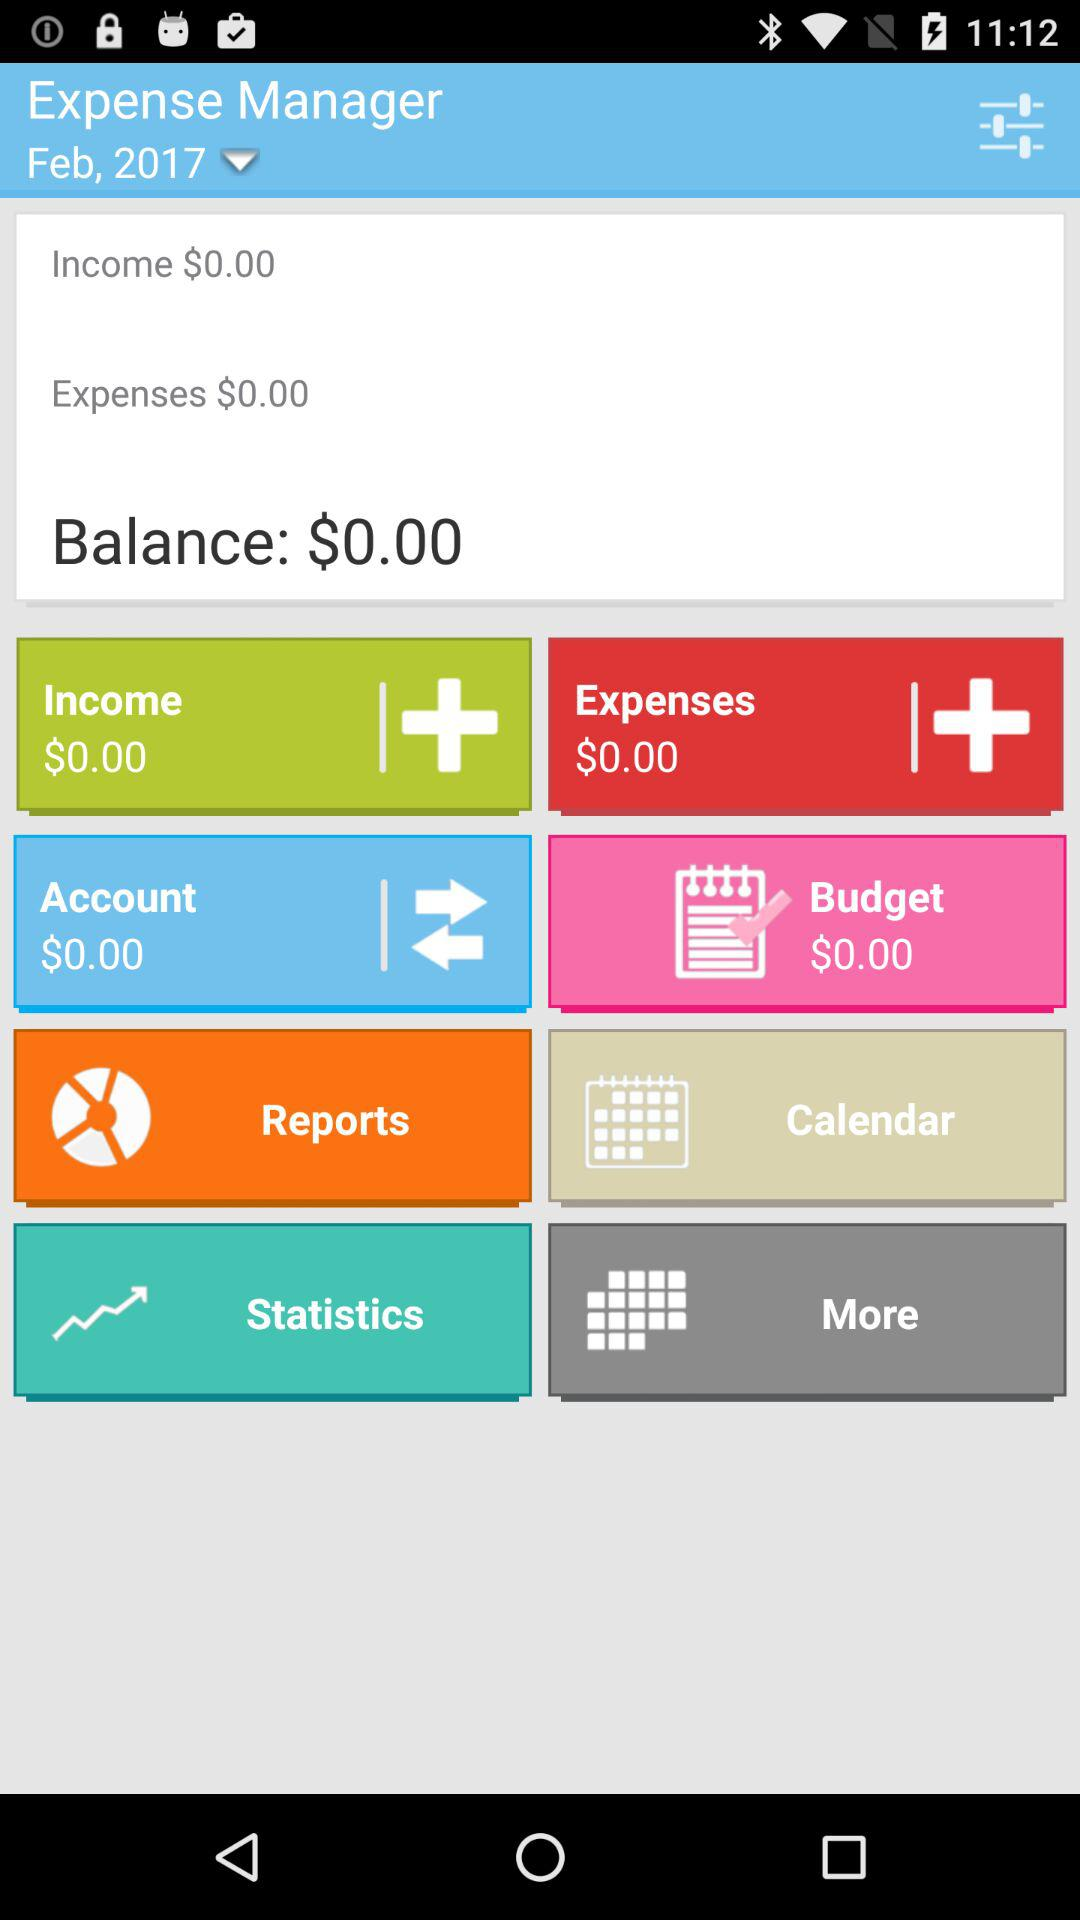What is the shown balance? The shown balance is $0.00. 